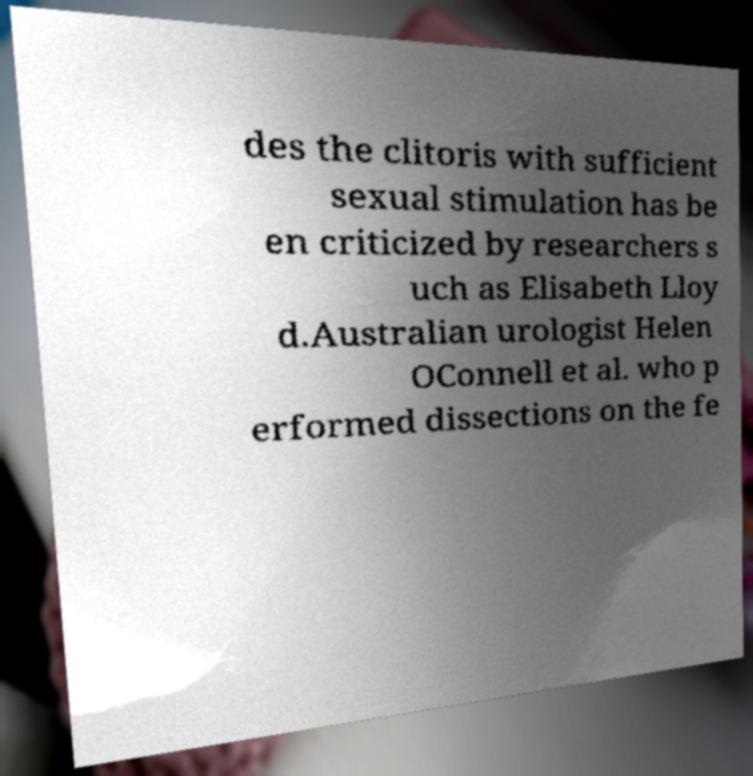There's text embedded in this image that I need extracted. Can you transcribe it verbatim? des the clitoris with sufficient sexual stimulation has be en criticized by researchers s uch as Elisabeth Lloy d.Australian urologist Helen OConnell et al. who p erformed dissections on the fe 